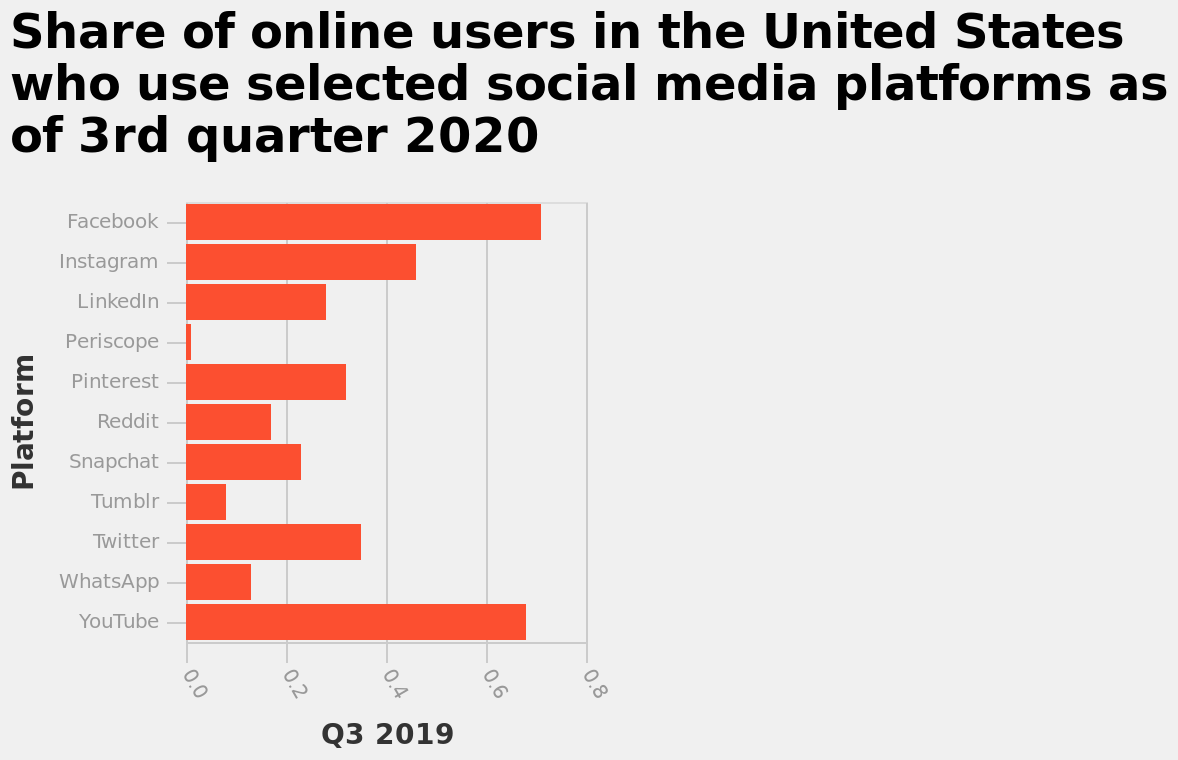<image>
How popular are Facebook and YouTube compared to Periscope? Facebook and YouTube are more popular than Periscope. Which platform has the lowest share?  Periscope. What is the starting point on the y-axis? The starting point on the y-axis is Facebook. Are Facebook and YouTube the only platforms mentioned? Yes, Facebook and YouTube are the only platforms mentioned. What is the ending point on the y-axis? The ending point on the y-axis is YouTube. 